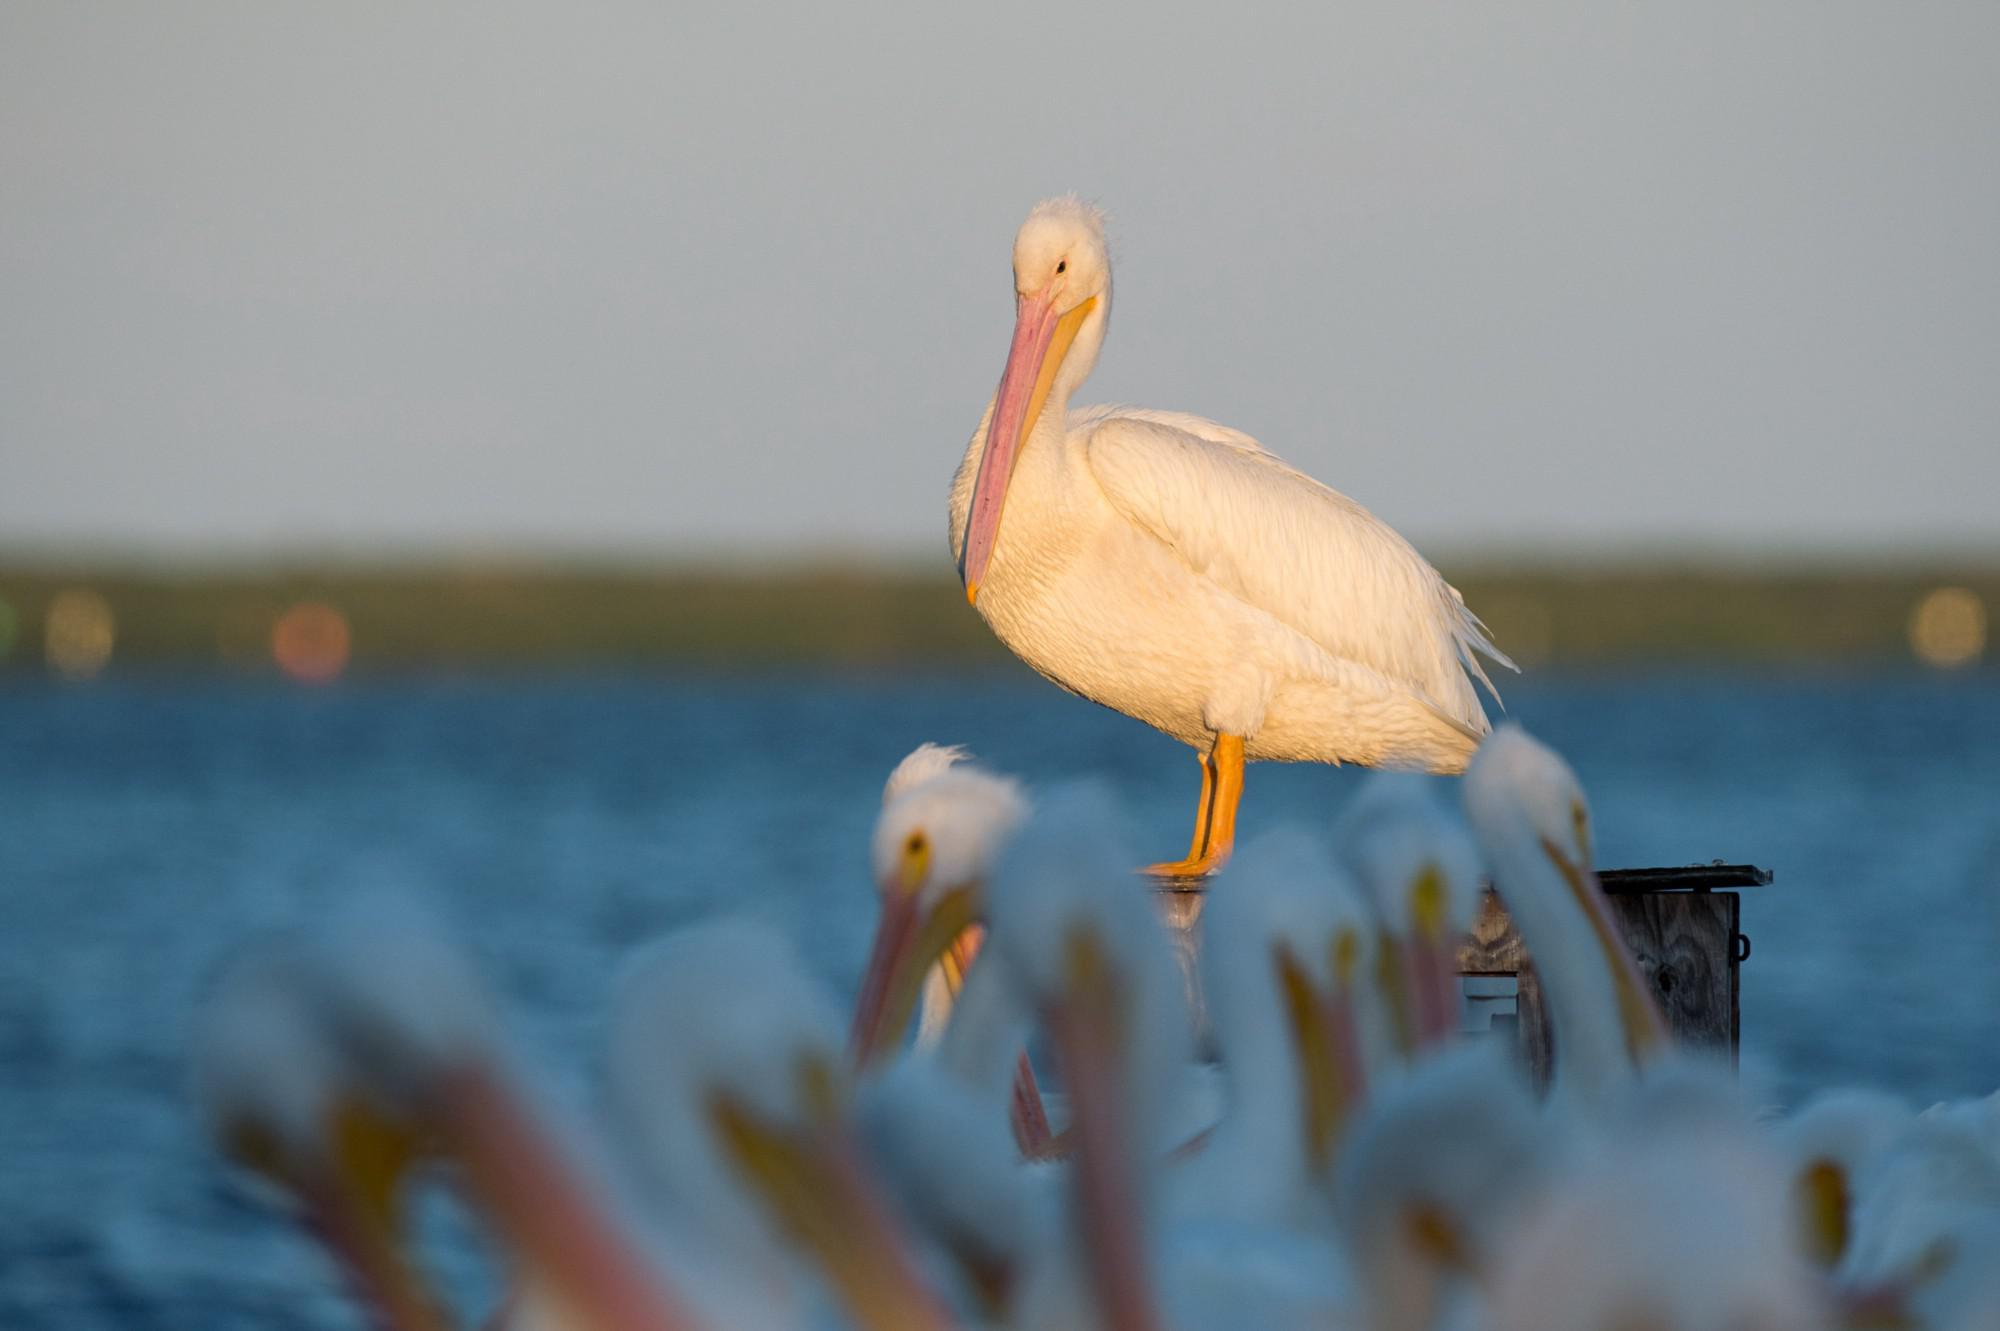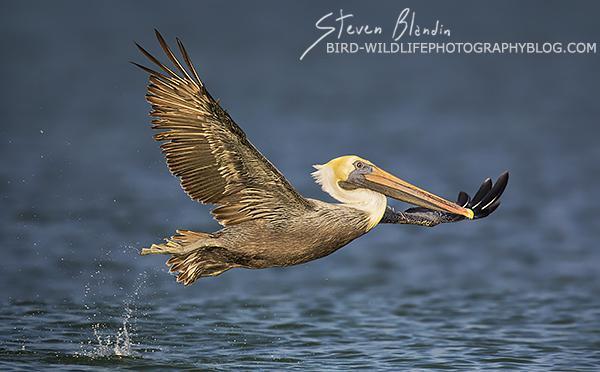The first image is the image on the left, the second image is the image on the right. Assess this claim about the two images: "The bird in the image on the right is flying". Correct or not? Answer yes or no. Yes. The first image is the image on the left, the second image is the image on the right. Given the left and right images, does the statement "At least two pelicans are present in one of the images." hold true? Answer yes or no. Yes. 